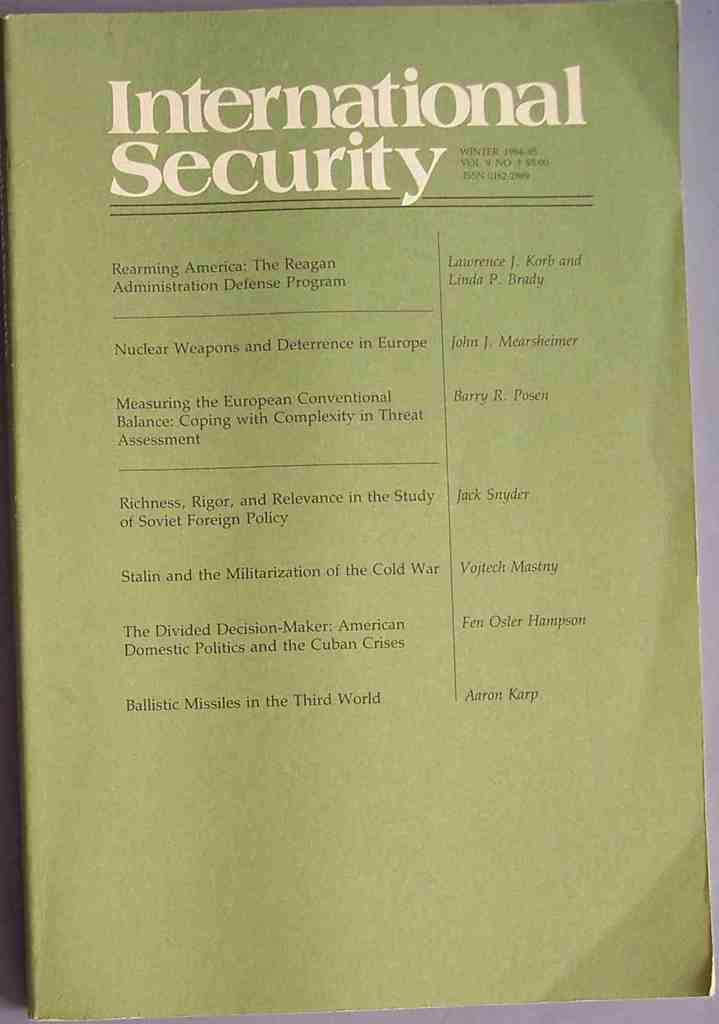Who is the last author listed?
Your answer should be compact. Aaron karp. 